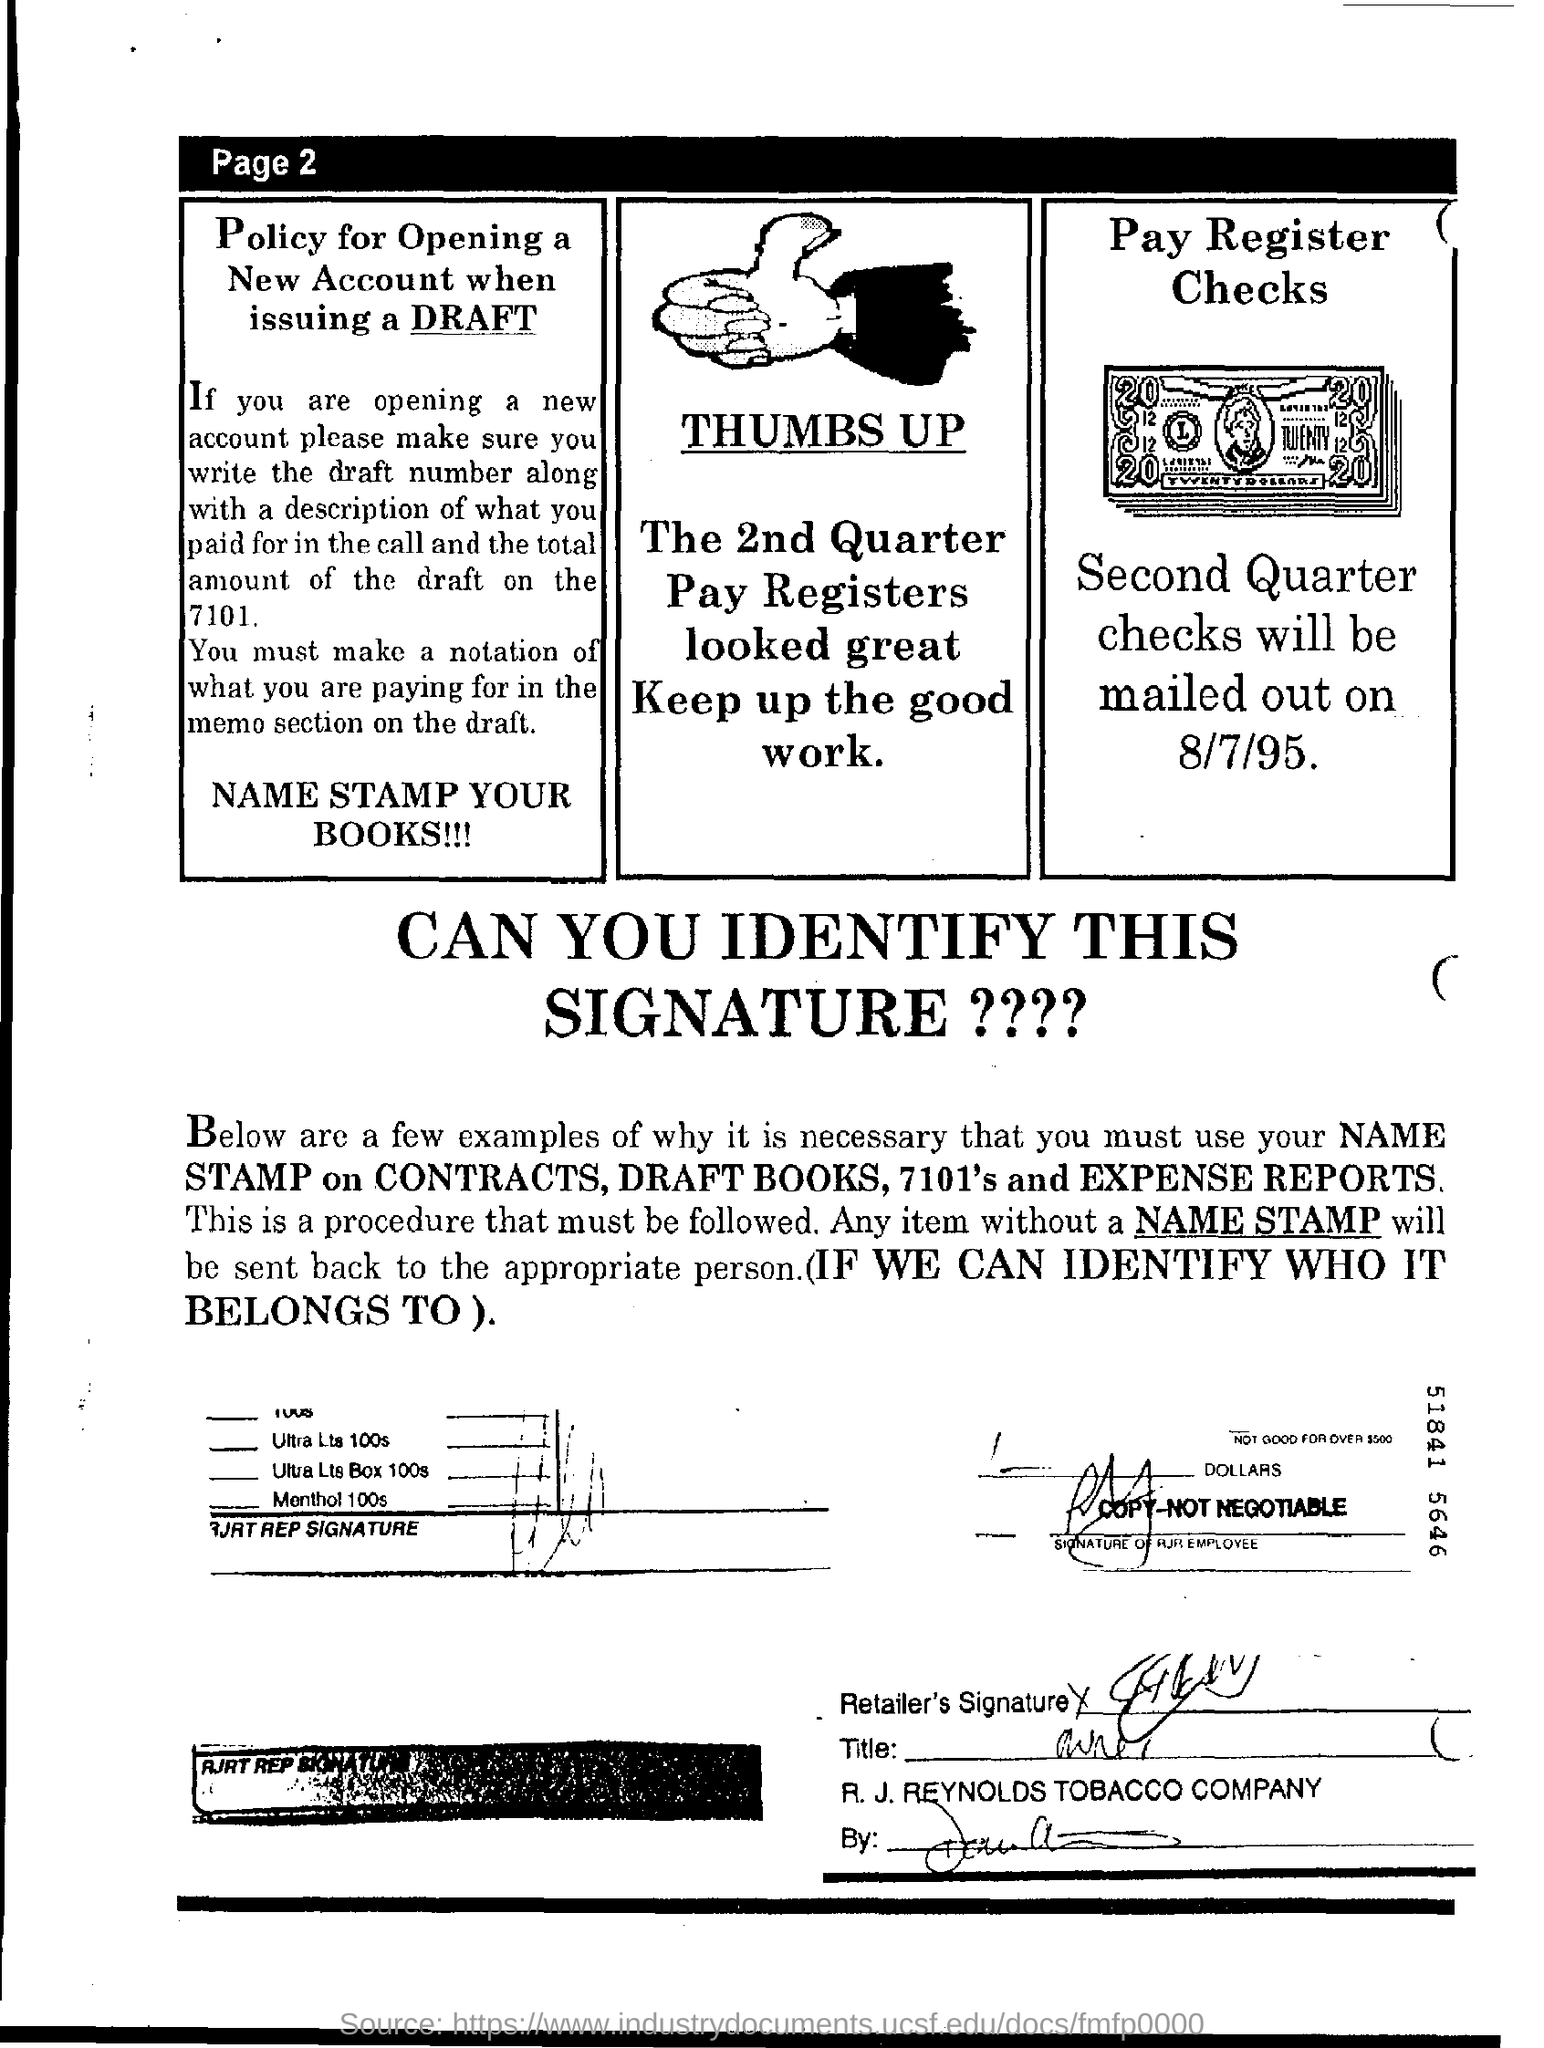When will second quarter checks be mailed out?
Make the answer very short. 8/7/95. 